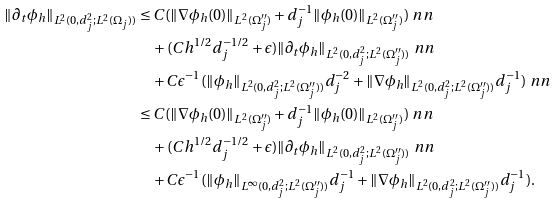Convert formula to latex. <formula><loc_0><loc_0><loc_500><loc_500>\| \partial _ { t } \phi _ { h } \| _ { L ^ { 2 } ( 0 , d _ { j } ^ { 2 } ; L ^ { 2 } ( \Omega _ { j } ) ) } & \leq C ( \| \nabla \phi _ { h } ( 0 ) \| _ { L ^ { 2 } ( \Omega _ { j } ^ { \prime \prime } ) } + d _ { j } ^ { - 1 } \| \phi _ { h } ( 0 ) \| _ { L ^ { 2 } ( \Omega _ { j } ^ { \prime \prime } ) } ) \ n n \\ & \quad + ( C h ^ { 1 / 2 } d _ { j } ^ { - 1 / 2 } + \epsilon ) \| \partial _ { t } \phi _ { h } \| _ { L ^ { 2 } ( 0 , d _ { j } ^ { 2 } ; L ^ { 2 } ( \Omega _ { j } ^ { \prime \prime } ) ) } \ n n \\ & \quad + C \epsilon ^ { - 1 } ( \| \phi _ { h } \| _ { L ^ { 2 } ( 0 , d _ { j } ^ { 2 } ; L ^ { 2 } ( \Omega _ { j } ^ { \prime \prime } ) ) } d _ { j } ^ { - 2 } + \| \nabla \phi _ { h } \| _ { L ^ { 2 } ( 0 , d _ { j } ^ { 2 } ; L ^ { 2 } ( \Omega _ { j } ^ { \prime \prime } ) ) } d _ { j } ^ { - 1 } ) \ n n \\ & \leq C ( \| \nabla \phi _ { h } ( 0 ) \| _ { L ^ { 2 } ( \Omega _ { j } ^ { \prime \prime } ) } + d _ { j } ^ { - 1 } \| \phi _ { h } ( 0 ) \| _ { L ^ { 2 } ( \Omega _ { j } ^ { \prime \prime } ) } ) \ n n \\ & \quad + ( C h ^ { 1 / 2 } d _ { j } ^ { - 1 / 2 } + \epsilon ) \| \partial _ { t } \phi _ { h } \| _ { L ^ { 2 } ( 0 , d _ { j } ^ { 2 } ; L ^ { 2 } ( \Omega _ { j } ^ { \prime \prime } ) ) } \ n n \\ & \quad + C \epsilon ^ { - 1 } ( \| \phi _ { h } \| _ { L ^ { \infty } ( 0 , d _ { j } ^ { 2 } ; L ^ { 2 } ( \Omega _ { j } ^ { \prime \prime } ) ) } d _ { j } ^ { - 1 } + \| \nabla \phi _ { h } \| _ { L ^ { 2 } ( 0 , d _ { j } ^ { 2 } ; L ^ { 2 } ( \Omega _ { j } ^ { \prime \prime } ) ) } d _ { j } ^ { - 1 } ) .</formula> 